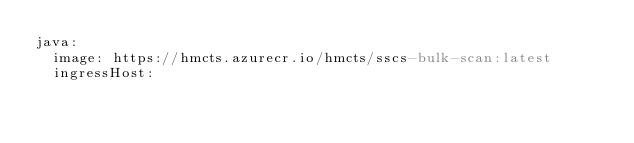Convert code to text. <code><loc_0><loc_0><loc_500><loc_500><_YAML_>java:
  image: https://hmcts.azurecr.io/hmcts/sscs-bulk-scan:latest
  ingressHost: 
</code> 